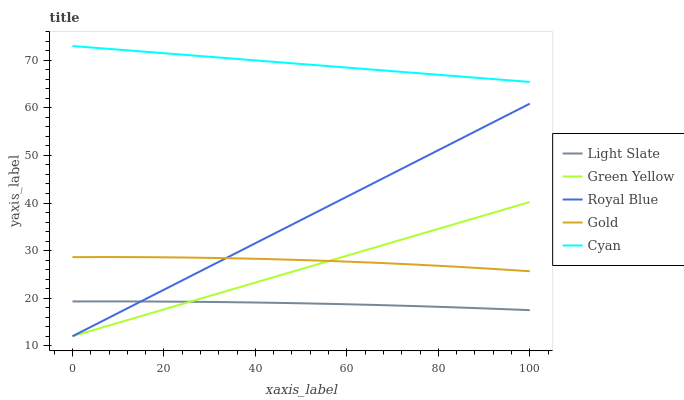Does Light Slate have the minimum area under the curve?
Answer yes or no. Yes. Does Cyan have the maximum area under the curve?
Answer yes or no. Yes. Does Royal Blue have the minimum area under the curve?
Answer yes or no. No. Does Royal Blue have the maximum area under the curve?
Answer yes or no. No. Is Green Yellow the smoothest?
Answer yes or no. Yes. Is Gold the roughest?
Answer yes or no. Yes. Is Royal Blue the smoothest?
Answer yes or no. No. Is Royal Blue the roughest?
Answer yes or no. No. Does Royal Blue have the lowest value?
Answer yes or no. Yes. Does Gold have the lowest value?
Answer yes or no. No. Does Cyan have the highest value?
Answer yes or no. Yes. Does Royal Blue have the highest value?
Answer yes or no. No. Is Light Slate less than Cyan?
Answer yes or no. Yes. Is Cyan greater than Gold?
Answer yes or no. Yes. Does Royal Blue intersect Light Slate?
Answer yes or no. Yes. Is Royal Blue less than Light Slate?
Answer yes or no. No. Is Royal Blue greater than Light Slate?
Answer yes or no. No. Does Light Slate intersect Cyan?
Answer yes or no. No. 